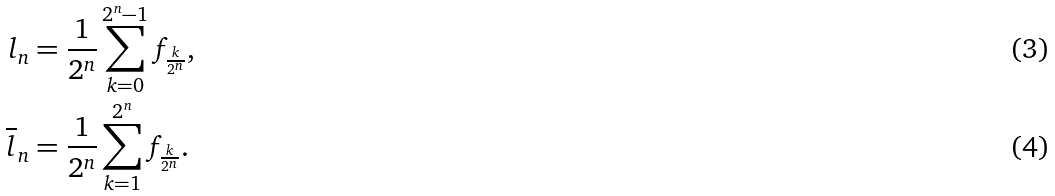<formula> <loc_0><loc_0><loc_500><loc_500>l _ { n } & = \frac { 1 } { 2 ^ { n } } \sum _ { k = 0 } ^ { 2 ^ { n } - 1 } f _ { \frac { k } { 2 ^ { n } } } , \\ \overline { l } _ { n } & = \frac { 1 } { 2 ^ { n } } \sum _ { k = 1 } ^ { 2 ^ { n } } f _ { \frac { k } { 2 ^ { n } } } .</formula> 